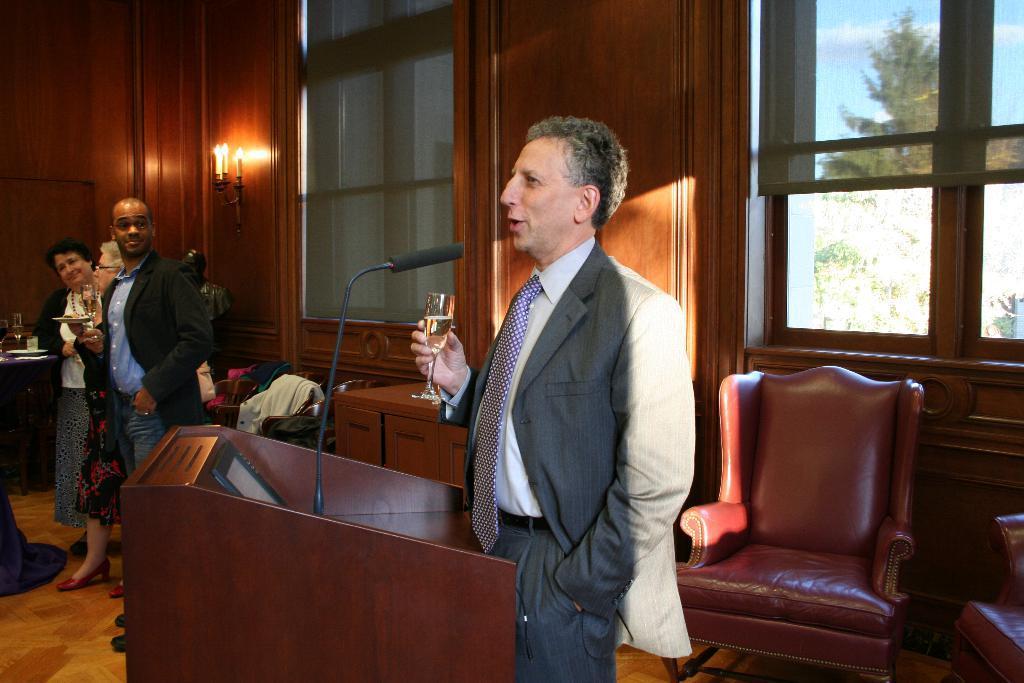How would you summarize this image in a sentence or two? This Images is clicked inside a room where it has chairs, podium, Mike. There is a man near the podium who is talking something. He hold ,he is holding a glass and there are 3 people on the left side two are women and one is man, there are candles on the top corner and there are Windows, there is a window on the right side corner. There are trees right side. Both men are wearing blazers. 